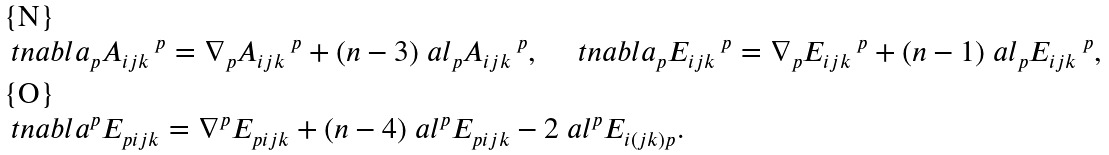Convert formula to latex. <formula><loc_0><loc_0><loc_500><loc_500>& \ t n a b l a _ { p } A _ { i j k } \, ^ { p } = \nabla _ { p } A _ { i j k } \, ^ { p } + ( n - 3 ) \ a l _ { p } A _ { i j k } \, ^ { p } , \quad \ t n a b l a _ { p } E _ { i j k } \, ^ { p } = \nabla _ { p } E _ { i j k } \, ^ { p } + ( n - 1 ) \ a l _ { p } E _ { i j k } \, ^ { p } , \\ & \ t n a b l a ^ { p } E _ { p i j k } = \nabla ^ { p } E _ { p i j k } + ( n - 4 ) \ a l ^ { p } E _ { p i j k } - 2 \ a l ^ { p } E _ { i ( j k ) p } .</formula> 